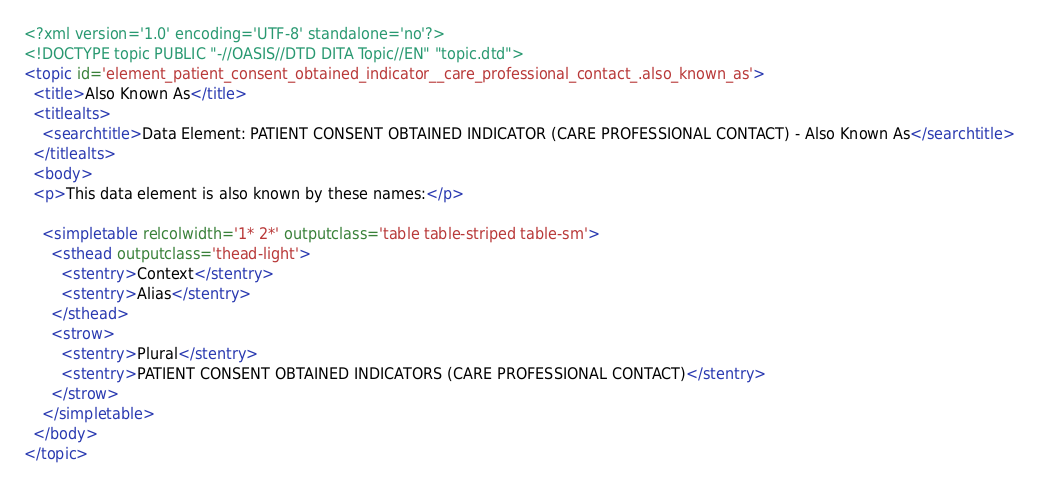Convert code to text. <code><loc_0><loc_0><loc_500><loc_500><_XML_><?xml version='1.0' encoding='UTF-8' standalone='no'?>
<!DOCTYPE topic PUBLIC "-//OASIS//DTD DITA Topic//EN" "topic.dtd">
<topic id='element_patient_consent_obtained_indicator__care_professional_contact_.also_known_as'>
  <title>Also Known As</title>
  <titlealts>
    <searchtitle>Data Element: PATIENT CONSENT OBTAINED INDICATOR (CARE PROFESSIONAL CONTACT) - Also Known As</searchtitle>
  </titlealts>
  <body>
  <p>This data element is also known by these names:</p>

    <simpletable relcolwidth='1* 2*' outputclass='table table-striped table-sm'>
      <sthead outputclass='thead-light'>
        <stentry>Context</stentry>
        <stentry>Alias</stentry>
      </sthead>
      <strow>
        <stentry>Plural</stentry>
        <stentry>PATIENT CONSENT OBTAINED INDICATORS (CARE PROFESSIONAL CONTACT)</stentry>
      </strow>
    </simpletable>
  </body>
</topic></code> 